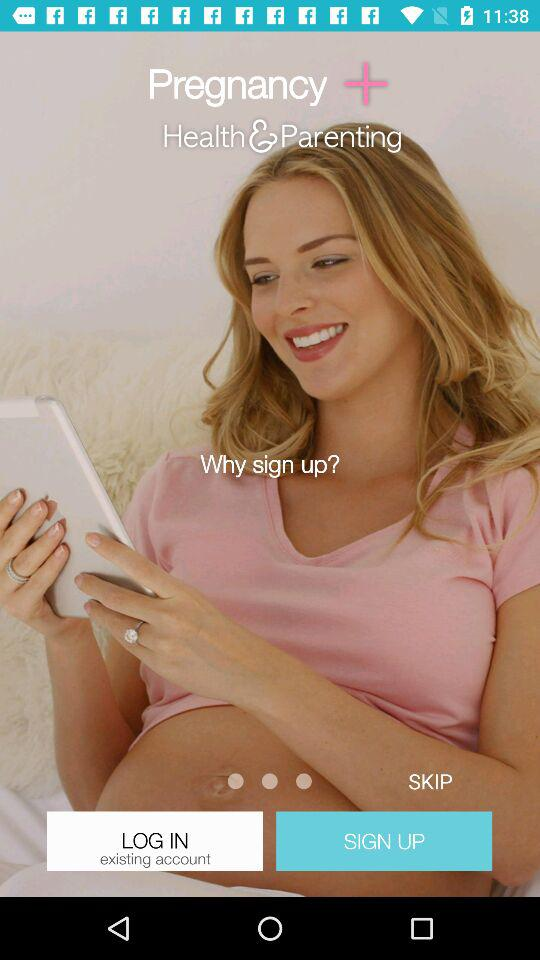What is the name of application? The name of the application "Pregnancy +". 